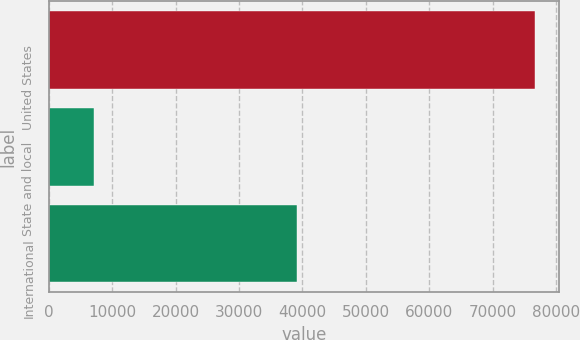Convert chart to OTSL. <chart><loc_0><loc_0><loc_500><loc_500><bar_chart><fcel>United States<fcel>State and local<fcel>International<nl><fcel>76642<fcel>7147<fcel>39081<nl></chart> 